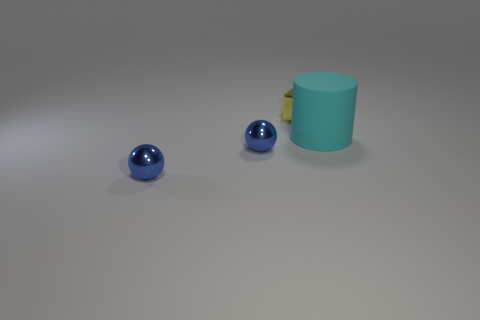Subtract all green spheres. Subtract all yellow cubes. How many spheres are left? 2 Add 4 blue shiny things. How many objects exist? 8 Subtract all blocks. How many objects are left? 3 Add 4 small yellow metal blocks. How many small yellow metal blocks are left? 5 Add 2 big cyan rubber cylinders. How many big cyan rubber cylinders exist? 3 Subtract 0 blue cylinders. How many objects are left? 4 Subtract all metal balls. Subtract all blocks. How many objects are left? 1 